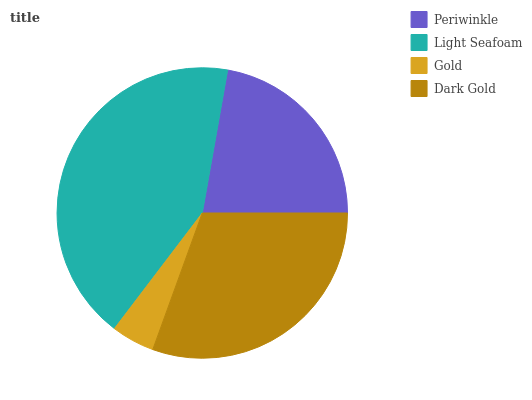Is Gold the minimum?
Answer yes or no. Yes. Is Light Seafoam the maximum?
Answer yes or no. Yes. Is Light Seafoam the minimum?
Answer yes or no. No. Is Gold the maximum?
Answer yes or no. No. Is Light Seafoam greater than Gold?
Answer yes or no. Yes. Is Gold less than Light Seafoam?
Answer yes or no. Yes. Is Gold greater than Light Seafoam?
Answer yes or no. No. Is Light Seafoam less than Gold?
Answer yes or no. No. Is Dark Gold the high median?
Answer yes or no. Yes. Is Periwinkle the low median?
Answer yes or no. Yes. Is Gold the high median?
Answer yes or no. No. Is Light Seafoam the low median?
Answer yes or no. No. 